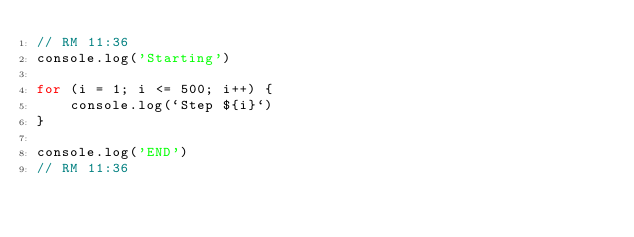Convert code to text. <code><loc_0><loc_0><loc_500><loc_500><_JavaScript_>// RM 11:36
console.log('Starting')

for (i = 1; i <= 500; i++) {
    console.log(`Step ${i}`)
}

console.log('END')
// RM 11:36</code> 